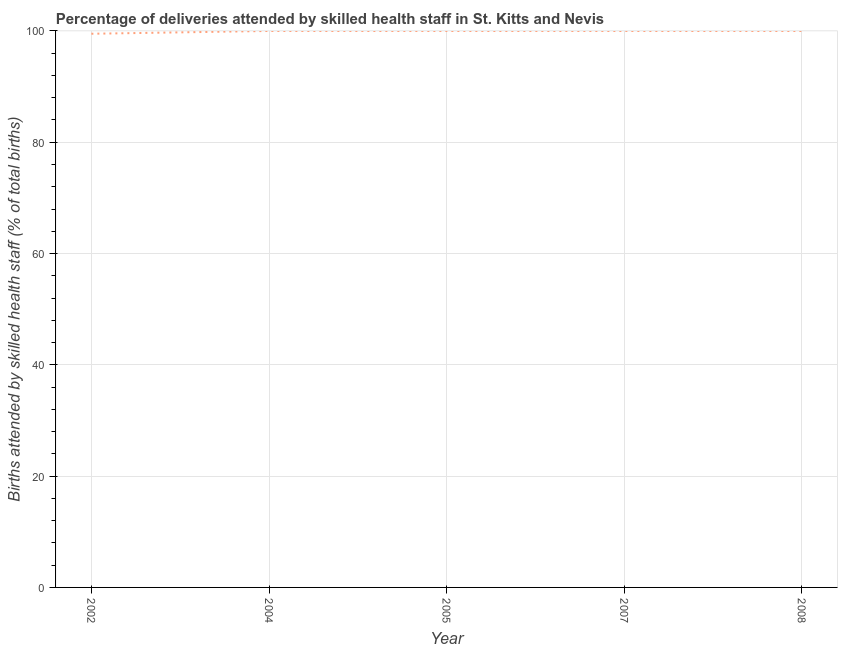What is the number of births attended by skilled health staff in 2002?
Your response must be concise. 99.5. Across all years, what is the maximum number of births attended by skilled health staff?
Make the answer very short. 100. Across all years, what is the minimum number of births attended by skilled health staff?
Make the answer very short. 99.5. What is the sum of the number of births attended by skilled health staff?
Ensure brevity in your answer.  499.5. What is the difference between the number of births attended by skilled health staff in 2005 and 2008?
Offer a very short reply. 0. What is the average number of births attended by skilled health staff per year?
Keep it short and to the point. 99.9. In how many years, is the number of births attended by skilled health staff greater than 80 %?
Provide a succinct answer. 5. Is the number of births attended by skilled health staff in 2007 less than that in 2008?
Offer a terse response. No. Does the number of births attended by skilled health staff monotonically increase over the years?
Your answer should be very brief. No. How many lines are there?
Provide a succinct answer. 1. How many years are there in the graph?
Your response must be concise. 5. Are the values on the major ticks of Y-axis written in scientific E-notation?
Offer a very short reply. No. Does the graph contain any zero values?
Keep it short and to the point. No. What is the title of the graph?
Make the answer very short. Percentage of deliveries attended by skilled health staff in St. Kitts and Nevis. What is the label or title of the Y-axis?
Your answer should be compact. Births attended by skilled health staff (% of total births). What is the Births attended by skilled health staff (% of total births) in 2002?
Provide a succinct answer. 99.5. What is the Births attended by skilled health staff (% of total births) in 2005?
Give a very brief answer. 100. What is the Births attended by skilled health staff (% of total births) in 2008?
Ensure brevity in your answer.  100. What is the difference between the Births attended by skilled health staff (% of total births) in 2002 and 2004?
Offer a very short reply. -0.5. What is the difference between the Births attended by skilled health staff (% of total births) in 2002 and 2007?
Ensure brevity in your answer.  -0.5. What is the difference between the Births attended by skilled health staff (% of total births) in 2004 and 2005?
Give a very brief answer. 0. What is the difference between the Births attended by skilled health staff (% of total births) in 2005 and 2008?
Provide a succinct answer. 0. What is the ratio of the Births attended by skilled health staff (% of total births) in 2004 to that in 2007?
Keep it short and to the point. 1. What is the ratio of the Births attended by skilled health staff (% of total births) in 2007 to that in 2008?
Your response must be concise. 1. 